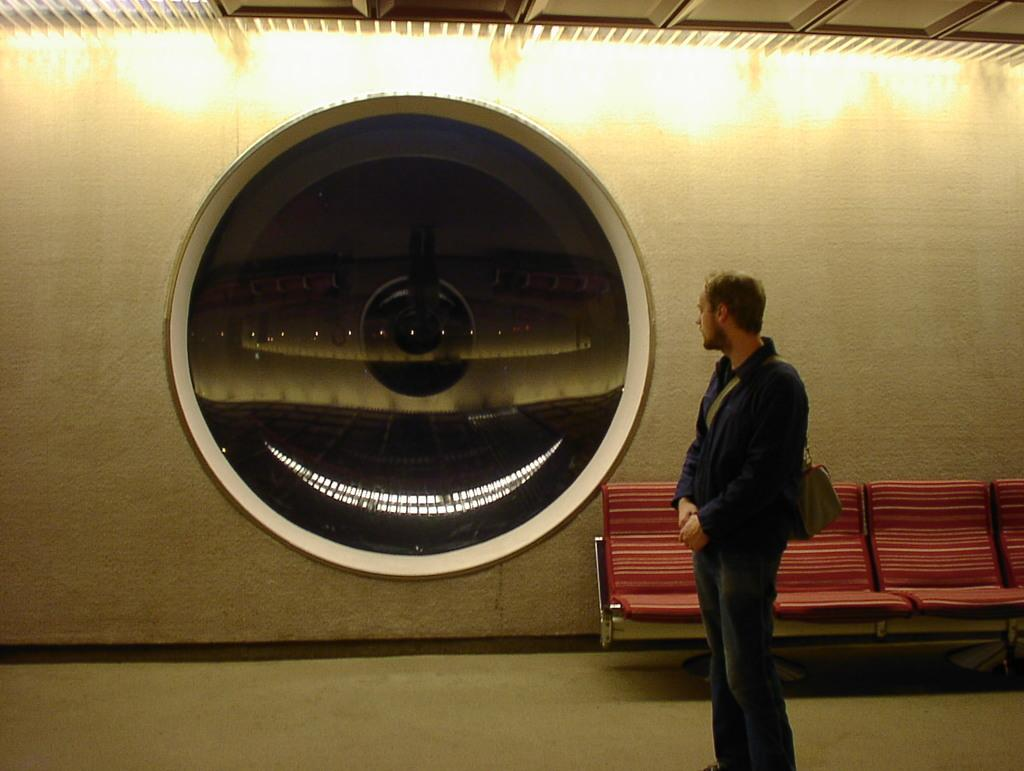Who is present in the image? There is a person in the image. What is the person holding? The person is holding a bag. What type of furniture can be seen in the image? There are chairs in the image. What object in the image has reflections? There is a glass with reflections in the image. What architectural elements are visible in the image? The wall and the roof are visible in the image. What type of soap is being used to clean the bulb in the image? There is no soap or bulb present in the image. Is there a battle taking place in the image? No, there is no battle depicted in the image. 